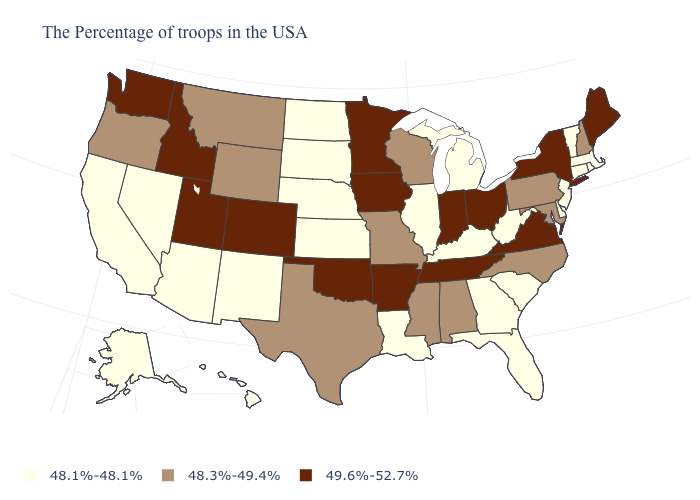Name the states that have a value in the range 49.6%-52.7%?
Short answer required. Maine, New York, Virginia, Ohio, Indiana, Tennessee, Arkansas, Minnesota, Iowa, Oklahoma, Colorado, Utah, Idaho, Washington. What is the value of New York?
Give a very brief answer. 49.6%-52.7%. What is the value of Minnesota?
Write a very short answer. 49.6%-52.7%. Among the states that border North Carolina , does Georgia have the lowest value?
Give a very brief answer. Yes. What is the value of Washington?
Write a very short answer. 49.6%-52.7%. Among the states that border Minnesota , which have the lowest value?
Be succinct. South Dakota, North Dakota. Among the states that border Montana , which have the highest value?
Short answer required. Idaho. What is the value of Pennsylvania?
Be succinct. 48.3%-49.4%. Name the states that have a value in the range 49.6%-52.7%?
Give a very brief answer. Maine, New York, Virginia, Ohio, Indiana, Tennessee, Arkansas, Minnesota, Iowa, Oklahoma, Colorado, Utah, Idaho, Washington. What is the lowest value in the South?
Give a very brief answer. 48.1%-48.1%. Is the legend a continuous bar?
Quick response, please. No. Which states have the lowest value in the West?
Quick response, please. New Mexico, Arizona, Nevada, California, Alaska, Hawaii. Which states have the highest value in the USA?
Give a very brief answer. Maine, New York, Virginia, Ohio, Indiana, Tennessee, Arkansas, Minnesota, Iowa, Oklahoma, Colorado, Utah, Idaho, Washington. What is the highest value in states that border Maine?
Be succinct. 48.3%-49.4%. 